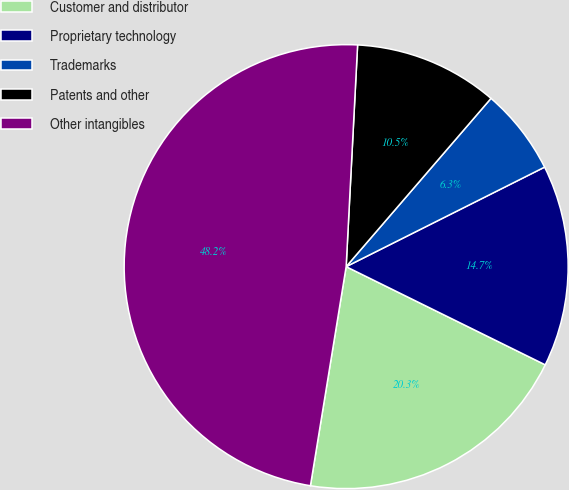Convert chart to OTSL. <chart><loc_0><loc_0><loc_500><loc_500><pie_chart><fcel>Customer and distributor<fcel>Proprietary technology<fcel>Trademarks<fcel>Patents and other<fcel>Other intangibles<nl><fcel>20.28%<fcel>14.69%<fcel>6.29%<fcel>10.49%<fcel>48.25%<nl></chart> 